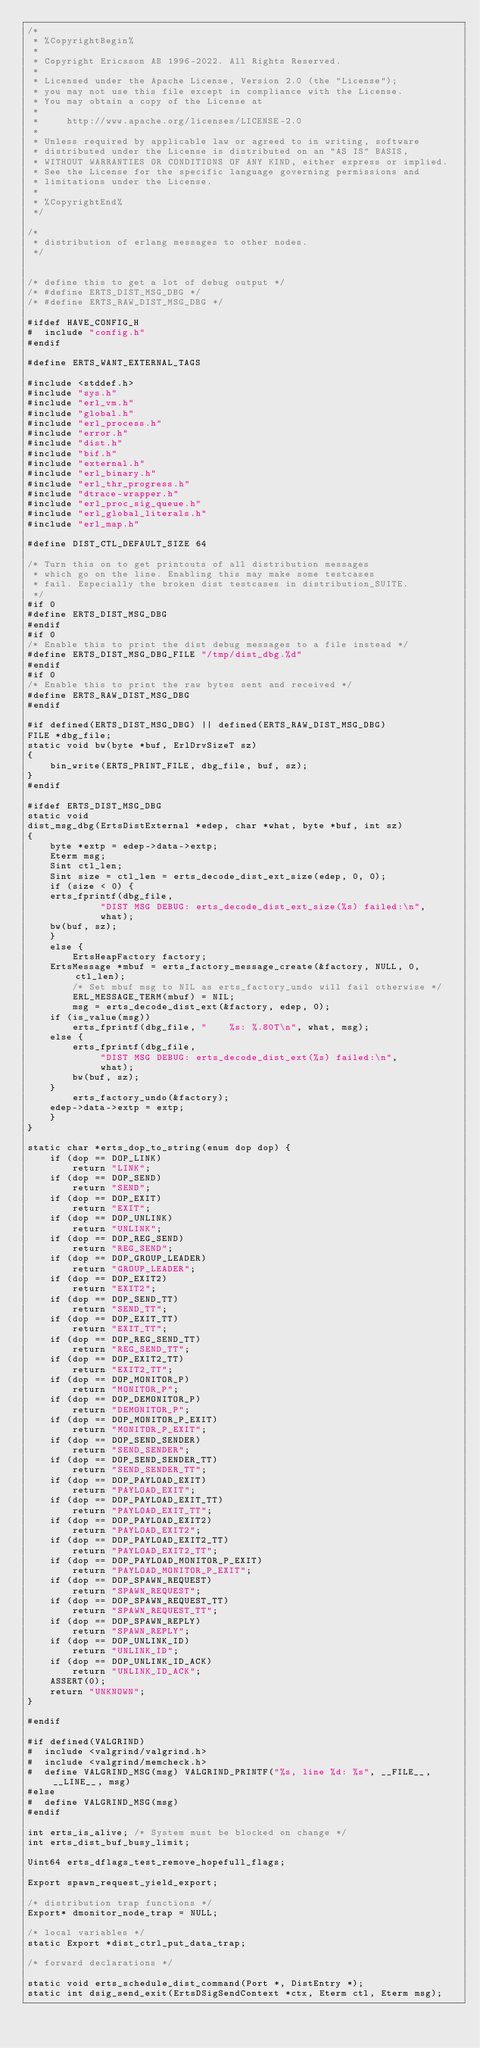Convert code to text. <code><loc_0><loc_0><loc_500><loc_500><_C_>/*
 * %CopyrightBegin%
 *
 * Copyright Ericsson AB 1996-2022. All Rights Reserved.
 *
 * Licensed under the Apache License, Version 2.0 (the "License");
 * you may not use this file except in compliance with the License.
 * You may obtain a copy of the License at
 *
 *     http://www.apache.org/licenses/LICENSE-2.0
 *
 * Unless required by applicable law or agreed to in writing, software
 * distributed under the License is distributed on an "AS IS" BASIS,
 * WITHOUT WARRANTIES OR CONDITIONS OF ANY KIND, either express or implied.
 * See the License for the specific language governing permissions and
 * limitations under the License.
 *
 * %CopyrightEnd%
 */

/*
 * distribution of erlang messages to other nodes.
 */


/* define this to get a lot of debug output */
/* #define ERTS_DIST_MSG_DBG */
/* #define ERTS_RAW_DIST_MSG_DBG */

#ifdef HAVE_CONFIG_H
#  include "config.h"
#endif

#define ERTS_WANT_EXTERNAL_TAGS

#include <stddef.h>
#include "sys.h"
#include "erl_vm.h"
#include "global.h"
#include "erl_process.h"
#include "error.h"
#include "dist.h"
#include "bif.h"
#include "external.h"
#include "erl_binary.h"
#include "erl_thr_progress.h"
#include "dtrace-wrapper.h"
#include "erl_proc_sig_queue.h"
#include "erl_global_literals.h"
#include "erl_map.h"

#define DIST_CTL_DEFAULT_SIZE 64

/* Turn this on to get printouts of all distribution messages
 * which go on the line. Enabling this may make some testcases
 * fail. Especially the broken dist testcases in distribution_SUITE.
 */
#if 0
#define ERTS_DIST_MSG_DBG
#endif
#if 0
/* Enable this to print the dist debug messages to a file instead */
#define ERTS_DIST_MSG_DBG_FILE "/tmp/dist_dbg.%d"
#endif
#if 0
/* Enable this to print the raw bytes sent and received */
#define ERTS_RAW_DIST_MSG_DBG
#endif

#if defined(ERTS_DIST_MSG_DBG) || defined(ERTS_RAW_DIST_MSG_DBG)
FILE *dbg_file;
static void bw(byte *buf, ErlDrvSizeT sz)
{
    bin_write(ERTS_PRINT_FILE, dbg_file, buf, sz);
}
#endif

#ifdef ERTS_DIST_MSG_DBG
static void
dist_msg_dbg(ErtsDistExternal *edep, char *what, byte *buf, int sz)
{
    byte *extp = edep->data->extp;
    Eterm msg;
    Sint ctl_len;
    Sint size = ctl_len = erts_decode_dist_ext_size(edep, 0, 0);
    if (size < 0) {
	erts_fprintf(dbg_file,
		     "DIST MSG DEBUG: erts_decode_dist_ext_size(%s) failed:\n",
		     what);
	bw(buf, sz);
    }
    else {
        ErtsHeapFactory factory;
	ErtsMessage *mbuf = erts_factory_message_create(&factory, NULL, 0, ctl_len);
        /* Set mbuf msg to NIL as erts_factory_undo will fail otherwise */
        ERL_MESSAGE_TERM(mbuf) = NIL;
        msg = erts_decode_dist_ext(&factory, edep, 0);
	if (is_value(msg))
	    erts_fprintf(dbg_file, "    %s: %.80T\n", what, msg);
	else {
	    erts_fprintf(dbg_file,
			 "DIST MSG DEBUG: erts_decode_dist_ext(%s) failed:\n",
			 what);
	    bw(buf, sz);
	}
        erts_factory_undo(&factory);
	edep->data->extp = extp;
    }
}

static char *erts_dop_to_string(enum dop dop) {
    if (dop == DOP_LINK)
        return "LINK";
    if (dop == DOP_SEND)
        return "SEND";
    if (dop == DOP_EXIT)
        return "EXIT";
    if (dop == DOP_UNLINK)
        return "UNLINK";
    if (dop == DOP_REG_SEND)
        return "REG_SEND";
    if (dop == DOP_GROUP_LEADER)
        return "GROUP_LEADER";
    if (dop == DOP_EXIT2)
        return "EXIT2";
    if (dop == DOP_SEND_TT)
        return "SEND_TT";
    if (dop == DOP_EXIT_TT)
        return "EXIT_TT";
    if (dop == DOP_REG_SEND_TT)
        return "REG_SEND_TT";
    if (dop == DOP_EXIT2_TT)
        return "EXIT2_TT";
    if (dop == DOP_MONITOR_P)
        return "MONITOR_P";
    if (dop == DOP_DEMONITOR_P)
        return "DEMONITOR_P";
    if (dop == DOP_MONITOR_P_EXIT)
        return "MONITOR_P_EXIT";
    if (dop == DOP_SEND_SENDER)
        return "SEND_SENDER";
    if (dop == DOP_SEND_SENDER_TT)
        return "SEND_SENDER_TT";
    if (dop == DOP_PAYLOAD_EXIT)
        return "PAYLOAD_EXIT";
    if (dop == DOP_PAYLOAD_EXIT_TT)
        return "PAYLOAD_EXIT_TT";
    if (dop == DOP_PAYLOAD_EXIT2)
        return "PAYLOAD_EXIT2";
    if (dop == DOP_PAYLOAD_EXIT2_TT)
        return "PAYLOAD_EXIT2_TT";
    if (dop == DOP_PAYLOAD_MONITOR_P_EXIT)
        return "PAYLOAD_MONITOR_P_EXIT";
    if (dop == DOP_SPAWN_REQUEST)
        return "SPAWN_REQUEST";
    if (dop == DOP_SPAWN_REQUEST_TT)
        return "SPAWN_REQUEST_TT";
    if (dop == DOP_SPAWN_REPLY)
        return "SPAWN_REPLY";
    if (dop == DOP_UNLINK_ID)
        return "UNLINK_ID";
    if (dop == DOP_UNLINK_ID_ACK)
        return "UNLINK_ID_ACK";
    ASSERT(0);
    return "UNKNOWN";
}

#endif

#if defined(VALGRIND)
#  include <valgrind/valgrind.h>
#  include <valgrind/memcheck.h>
#  define VALGRIND_MSG(msg) VALGRIND_PRINTF("%s, line %d: %s", __FILE__, __LINE__, msg)
#else
#  define VALGRIND_MSG(msg)
#endif

int erts_is_alive; /* System must be blocked on change */
int erts_dist_buf_busy_limit;

Uint64 erts_dflags_test_remove_hopefull_flags;

Export spawn_request_yield_export;

/* distribution trap functions */
Export* dmonitor_node_trap = NULL;

/* local variables */
static Export *dist_ctrl_put_data_trap;

/* forward declarations */

static void erts_schedule_dist_command(Port *, DistEntry *);
static int dsig_send_exit(ErtsDSigSendContext *ctx, Eterm ctl, Eterm msg);</code> 